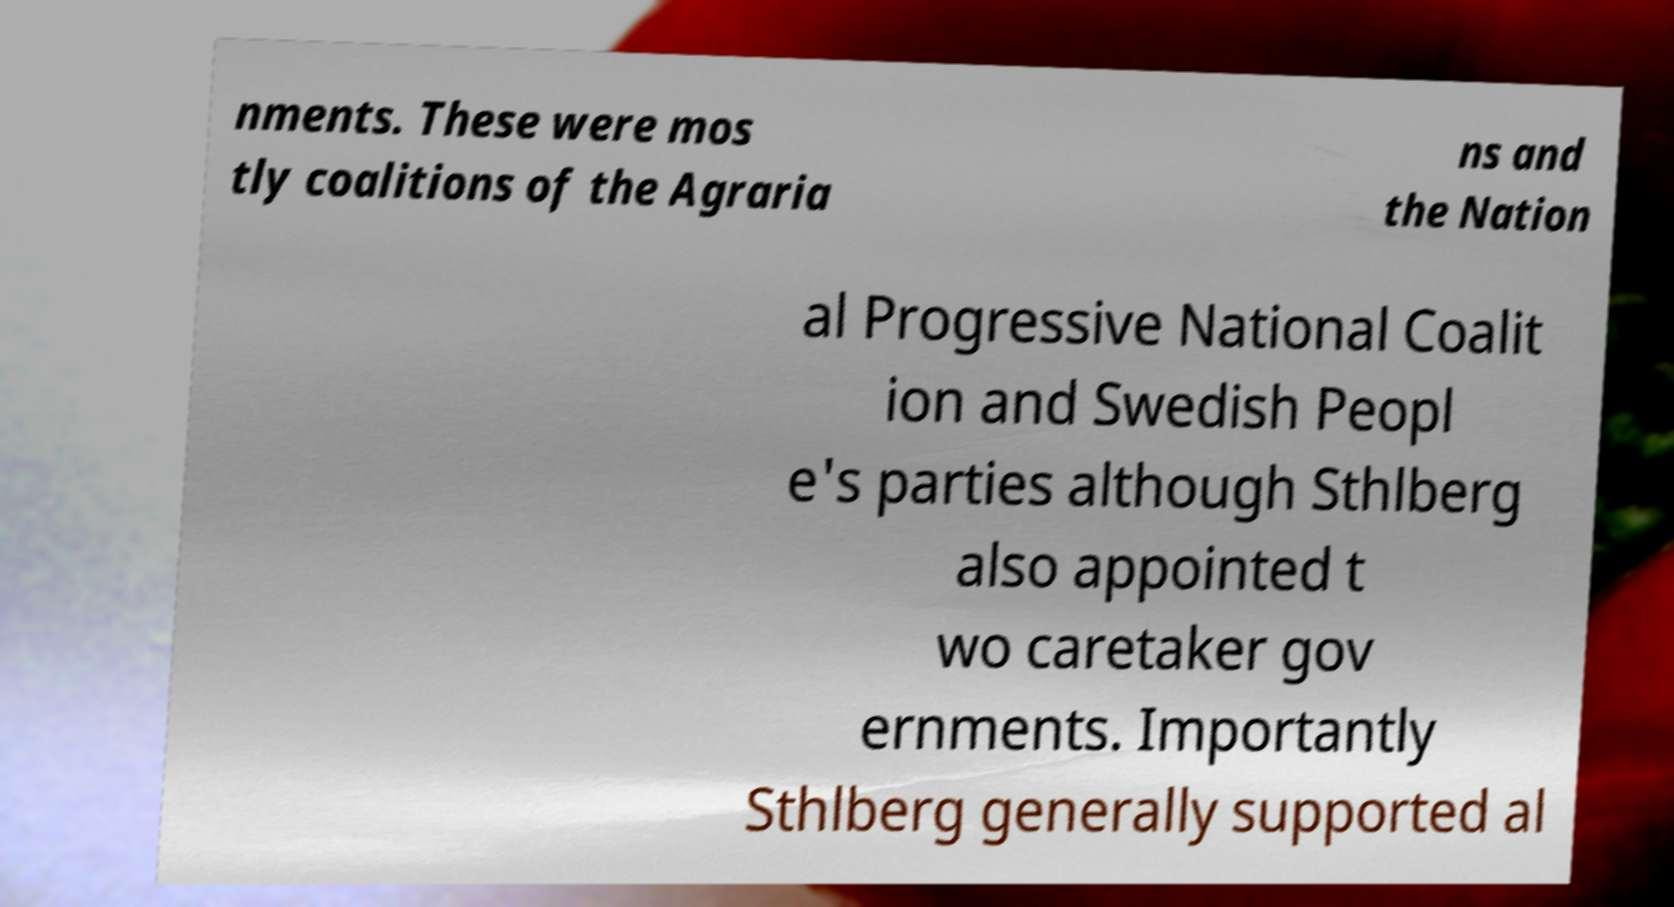For documentation purposes, I need the text within this image transcribed. Could you provide that? nments. These were mos tly coalitions of the Agraria ns and the Nation al Progressive National Coalit ion and Swedish Peopl e's parties although Sthlberg also appointed t wo caretaker gov ernments. Importantly Sthlberg generally supported al 